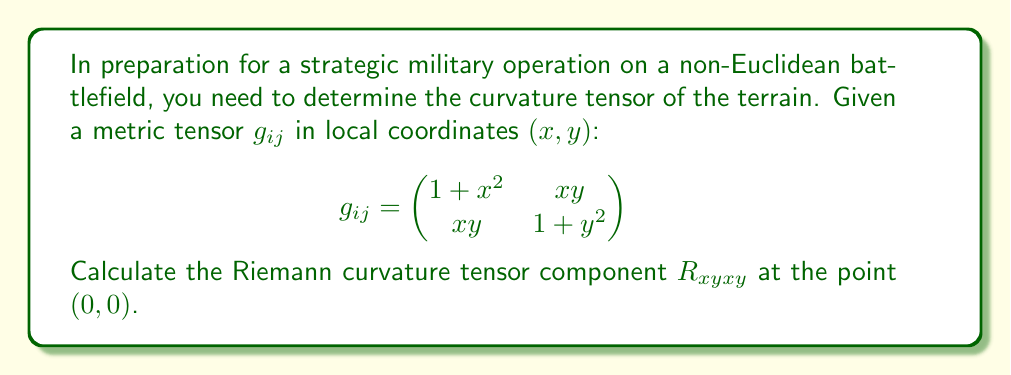Can you solve this math problem? To calculate the Riemann curvature tensor component $R_{xyxy}$, we'll follow these steps:

1) First, we need to calculate the Christoffel symbols $\Gamma^k_{ij}$ using the formula:

   $$\Gamma^k_{ij} = \frac{1}{2}g^{kl}(\partial_i g_{jl} + \partial_j g_{il} - \partial_l g_{ij})$$

2) We need the inverse metric $g^{ij}$. At (0, 0), $g_{ij} = \begin{pmatrix} 1 & 0 \\ 0 & 1 \end{pmatrix}$, so $g^{ij}$ is the same.

3) Calculating the non-zero Christoffel symbols at (0, 0):
   
   $\Gamma^x_{xx} = \frac{1}{2}(2x) = 0$
   $\Gamma^x_{xy} = \Gamma^x_{yx} = \frac{1}{2}y = 0$
   $\Gamma^y_{xy} = \Gamma^y_{yx} = \frac{1}{2}x = 0$
   $\Gamma^y_{yy} = \frac{1}{2}(2y) = 0$

4) The Riemann curvature tensor is given by:

   $$R^i_{jkl} = \partial_k \Gamma^i_{jl} - \partial_l \Gamma^i_{jk} + \Gamma^i_{km}\Gamma^m_{jl} - \Gamma^i_{lm}\Gamma^m_{jk}$$

5) Calculating $R_{xyxy} = g_{xm}R^m_{yxy}$:

   $$\begin{align}
   R_{xyxy} &= g_{xx}R^x_{yxy} + g_{xy}R^y_{yxy} \\
   &= 1 \cdot (\partial_x \Gamma^x_{yy} - \partial_y \Gamma^x_{yx} + \Gamma^x_{xx}\Gamma^x_{yy} + \Gamma^x_{xy}\Gamma^y_{yy} - \Gamma^x_{yx}\Gamma^x_{xy} - \Gamma^x_{yy}\Gamma^y_{xy}) \\
   &+ 0 \cdot (\partial_x \Gamma^y_{yy} - \partial_y \Gamma^y_{yx} + \Gamma^y_{xx}\Gamma^x_{yy} + \Gamma^y_{xy}\Gamma^y_{yy} - \Gamma^y_{yx}\Gamma^x_{xy} - \Gamma^y_{yy}\Gamma^y_{xy})
   \end{align}$$

6) Evaluating at (0, 0):
   
   $$R_{xyxy} = \partial_x (0) - \partial_y (\frac{1}{2}x) + 0 - 0 - 0 - 0 = -\frac{1}{2}$$

Thus, the Riemann curvature tensor component $R_{xyxy}$ at (0, 0) is $-\frac{1}{2}$.
Answer: $-\frac{1}{2}$ 